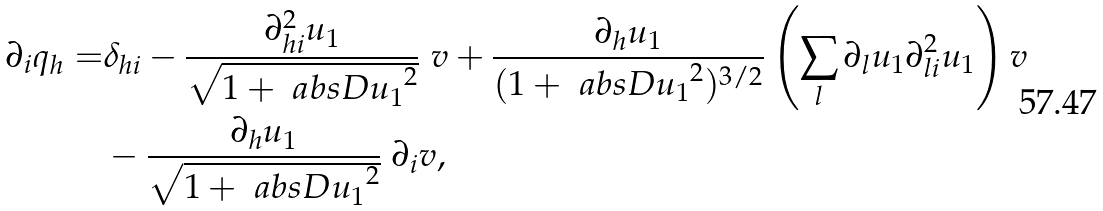<formula> <loc_0><loc_0><loc_500><loc_500>\partial _ { i } q _ { h } = & \delta _ { h i } - \frac { \partial ^ { 2 } _ { h i } u _ { 1 } } { \sqrt { 1 + \ a b s { D u _ { 1 } } ^ { 2 } } } \ v + \frac { \partial _ { h } u _ { 1 } } { ( 1 + \ a b s { D u _ { 1 } } ^ { 2 } ) ^ { 3 / 2 } } \left ( \sum _ { l } \partial _ { l } u _ { 1 } \partial ^ { 2 } _ { l i } u _ { 1 } \right ) v \\ & - \frac { \partial _ { h } u _ { 1 } } { \sqrt { 1 + \ a b s { D u _ { 1 } } ^ { 2 } } } \ \partial _ { i } v , \\</formula> 